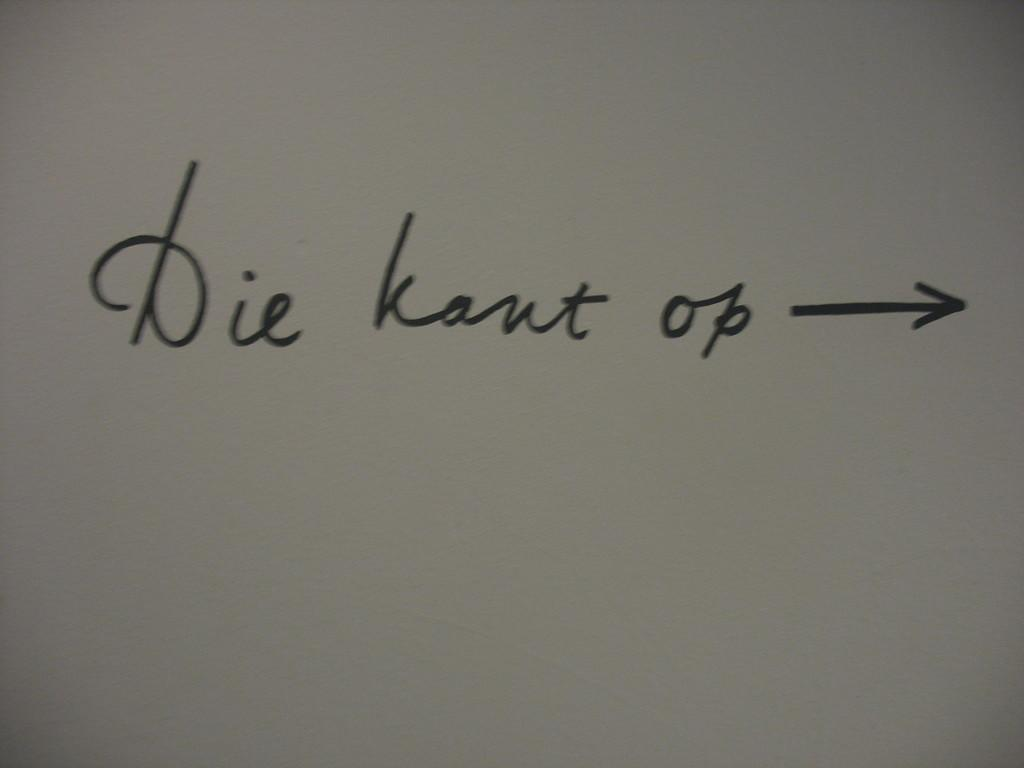<image>
Summarize the visual content of the image. White piece of paper that says "Die Kant OP" on it. 